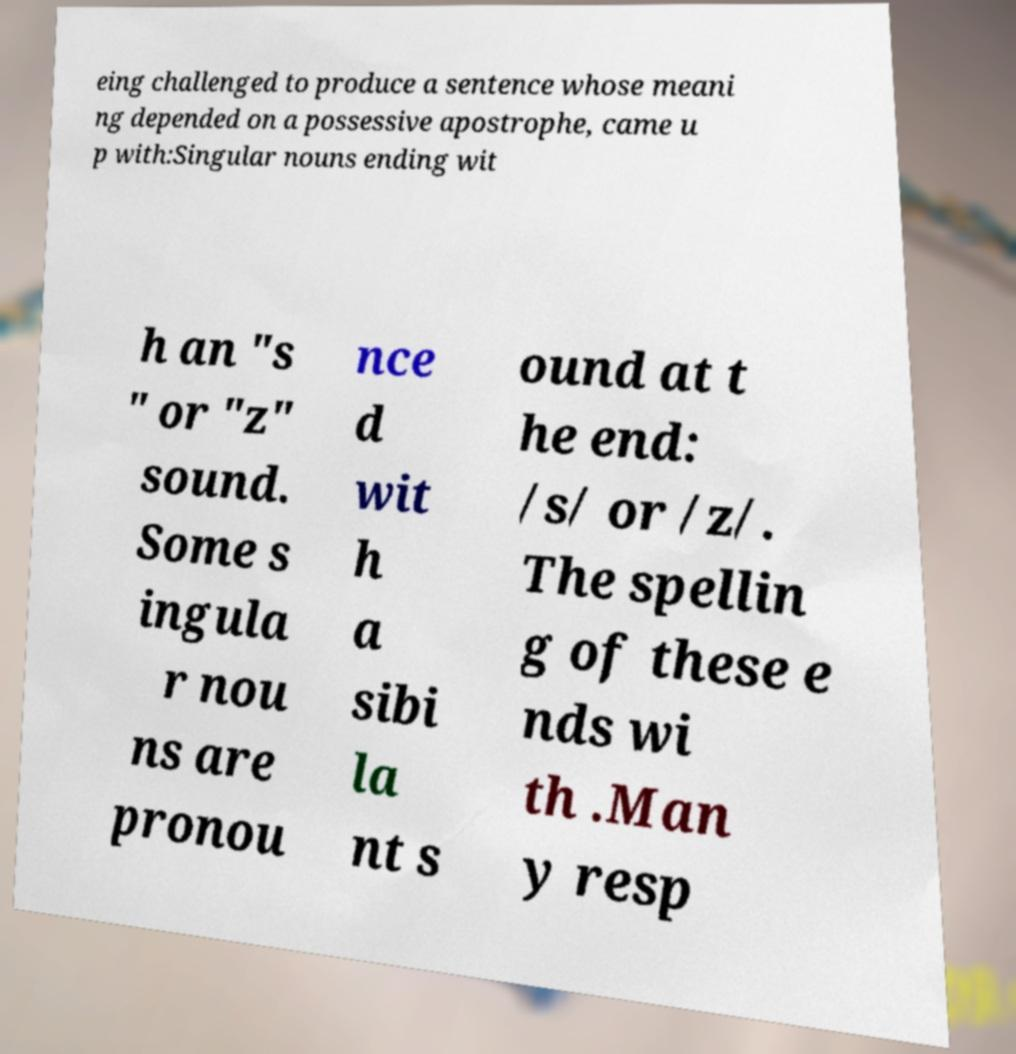Please identify and transcribe the text found in this image. eing challenged to produce a sentence whose meani ng depended on a possessive apostrophe, came u p with:Singular nouns ending wit h an "s " or "z" sound. Some s ingula r nou ns are pronou nce d wit h a sibi la nt s ound at t he end: /s/ or /z/. The spellin g of these e nds wi th .Man y resp 